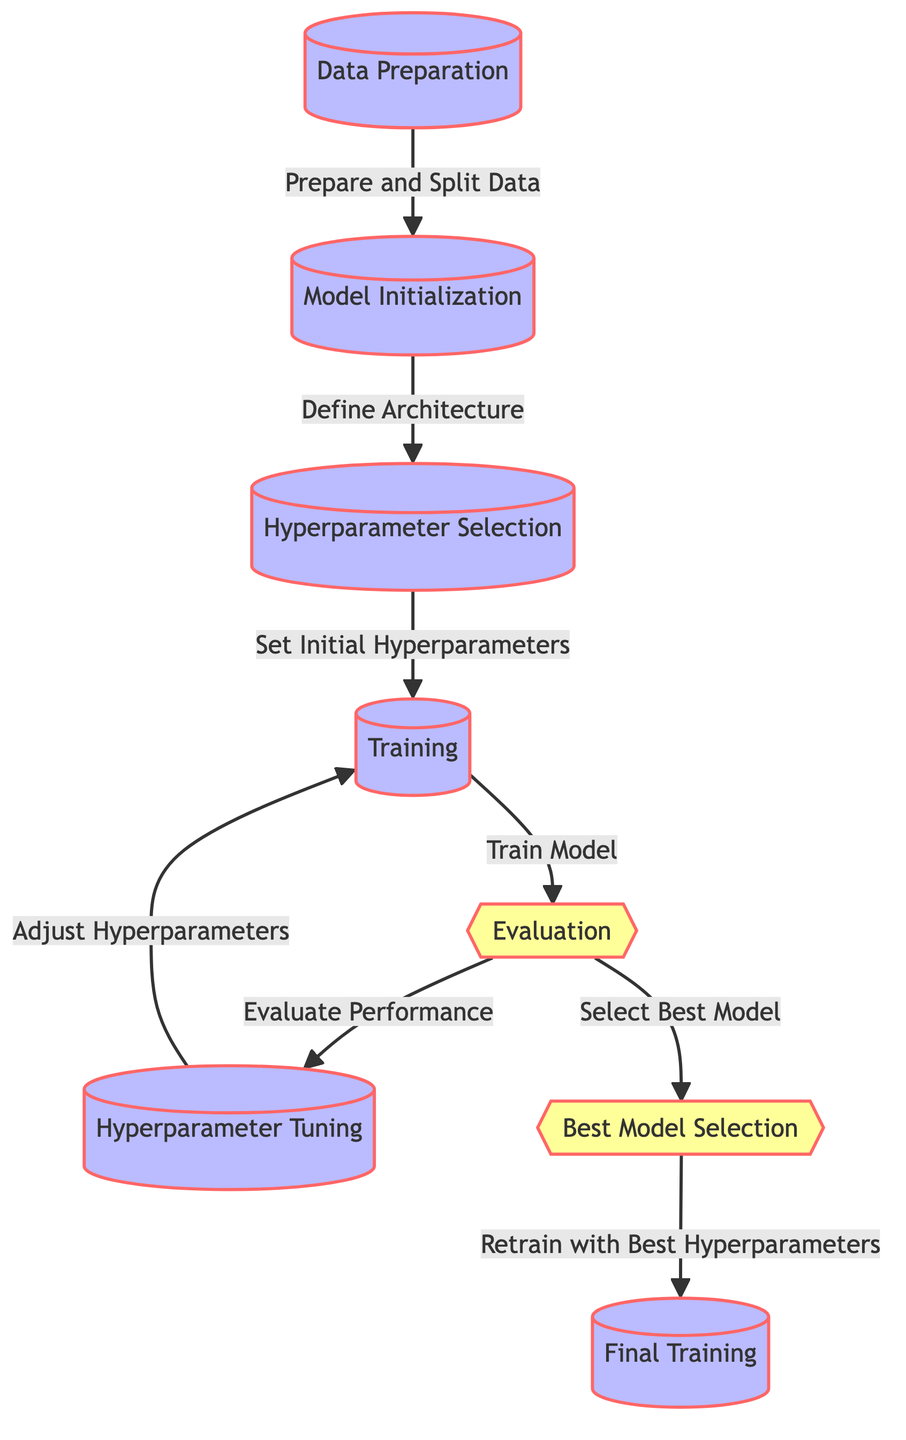What is the first step in the hyperparameter optimization workflow? The first step is "Data Preparation," which indicates the initial phase for organizing and preparing the data before any modeling activities.
Answer: Data Preparation How many main processes are there in the diagram? The diagram has six main processes: Data Preparation, Model Initialization, Hyperparameter Selection, Training, Hyperparameter Tuning, and Final Training.
Answer: Six What is the decision point following the evaluation step? After evaluation, there are two decision points: "Best Model Selection" and "Evaluation." This shows that both processes depend on the evaluation results.
Answer: Best Model Selection What action occurs after hyperparameter tuning? After hyperparameter tuning, the next action is training, indicating that the model will be retrained with the adjusted hyperparameters.
Answer: Training Which process involves defining the architecture? The process of defining the architecture is performed during "Model Initialization," which sets up the framework for the neural network.
Answer: Model Initialization What are the two outcomes following the evaluation step? The two outcomes following evaluation are "Select Best Model" and "Evaluate Performance," showing the options after assessing the model's performance.
Answer: Select Best Model, Evaluate Performance In which phase are initial hyperparameters set? The initial hyperparameters are set during the "Hyperparameter Selection" phase, as this step is dedicated to deciding the parameters to tune.
Answer: Hyperparameter Selection What does the final training process depend on? The final training process depends on the best hyperparameters obtained from the "Best Model Selection," ensuring optimal model training.
Answer: Best Model Selection 